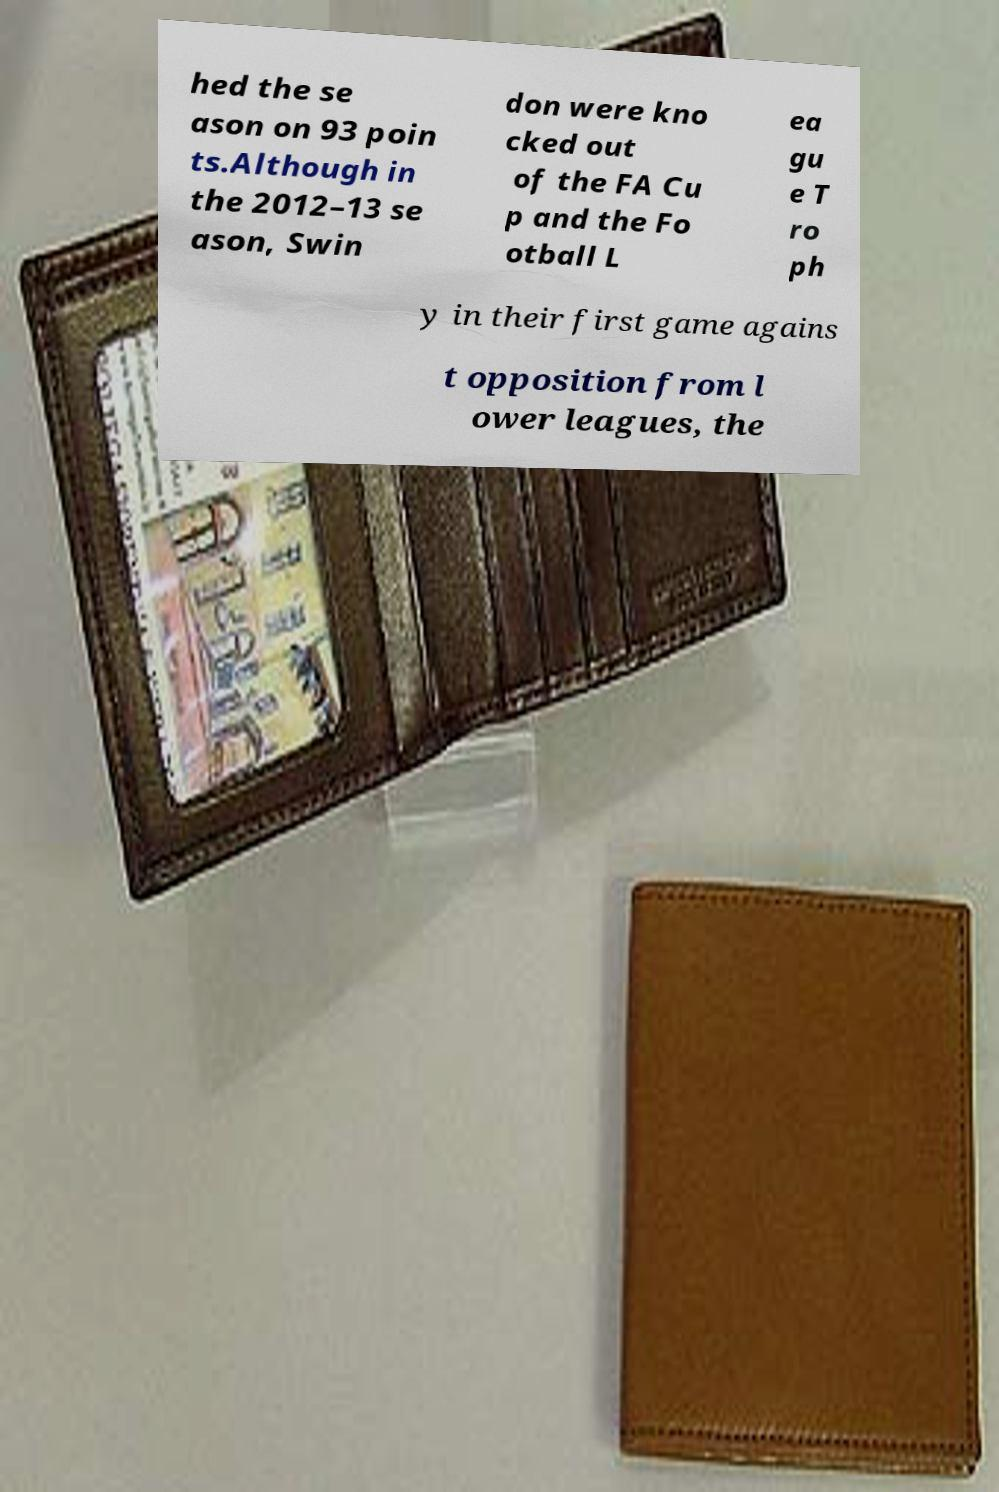There's text embedded in this image that I need extracted. Can you transcribe it verbatim? hed the se ason on 93 poin ts.Although in the 2012–13 se ason, Swin don were kno cked out of the FA Cu p and the Fo otball L ea gu e T ro ph y in their first game agains t opposition from l ower leagues, the 